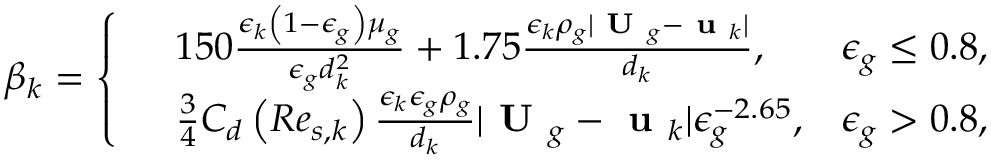Convert formula to latex. <formula><loc_0><loc_0><loc_500><loc_500>\beta _ { k } = \left \{ \begin{array} { r l r } & { 1 5 0 \frac { \epsilon _ { k } \left ( 1 - \epsilon _ { g } \right ) \mu _ { g } } { \epsilon _ { g } d _ { k } ^ { 2 } } + 1 . 7 5 \frac { \epsilon _ { k } \rho _ { g } | U _ { g } - u _ { k } | } { d _ { k } } , } & { \epsilon _ { g } \leq 0 . 8 , } \\ & { \frac { 3 } { 4 } C _ { d } \left ( R e _ { s , k } \right ) \frac { \epsilon _ { k } \epsilon _ { g } \rho _ { g } } { d _ { k } } | U _ { g } - u _ { k } | \epsilon _ { g } ^ { - 2 . 6 5 } , } & { \epsilon _ { g } > 0 . 8 , } \end{array}</formula> 